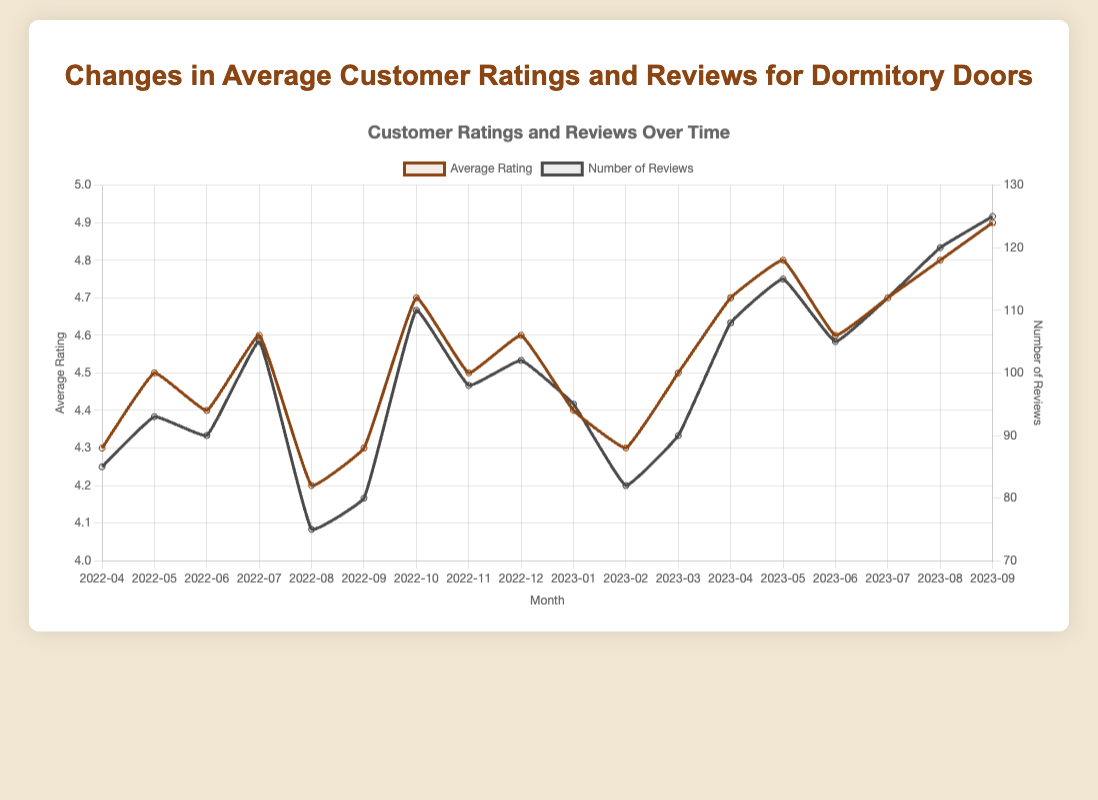What's the range of average customer ratings over the last 18 months? The smallest average rating is 4.2 (August 2022) and the highest is 4.9 (September 2023). The range is calculated as 4.9 - 4.2.
Answer: 0.7 Which month had the highest number of reviews, and what was the average rating that month? September 2023 had the highest number of reviews with 125 reviews, and the average rating that month was 4.9.
Answer: September 2023, 4.9 What is the average number of reviews per month over the last 18 months? Sum the number of reviews for each month: 85 + 93 + 90 + 105 + 75 + 80 + 110 + 98 + 102 + 95 + 82 + 90 + 108 + 115 + 105 + 112 + 120 + 125, then divide by 18. (1670/18)
Answer: 92.78 How did the average customer rating change from April 2022 to September 2023? The average rating in April 2022 was 4.3 and it increased to 4.9 in September 2023. The change is calculated as 4.9 - 4.3.
Answer: +0.6 Which two consecutive months show the largest increase in average ratings? Compare the difference in average ratings between consecutive months and find the largest increase. Between September 2022 (4.3) and October 2022 (4.7), the increase is 0.4, which is the largest.
Answer: September to October 2022 During which month did the reviews decrease while the average rating increased, compared to the previous month? Compare the number of reviews and average rating month over month. From June (90 reviews, 4.4) to July 2022 (105 reviews, 4.6), reviews decreased from 105 to 75 in August 2022 but the average rating increased from 4.6 to 4.2.
Answer: August 2022 What trend do you observe in the number of reviews from February 2023 to September 2023? The trend in the number of reviews is increasing each month from February 2023 (82 reviews) to September 2023 (125 reviews).
Answer: Increasing In which month did the average rating equal the average rating of the entire period? Calculate the overall average rating and compare it to the monthly averages. Overall average rating is (4.3+4.5+4.4+4.6+4.2+4.3+4.7+4.5+4.6+4.4+4.3+4.5+4.7+4.8+4.6+4.7+4.8+4.9)/18 = 4.566. The closest month is November 2022 with 4.5, which rounds off.
Answer: November 2022 What pattern do you observe between the months with the highest average ratings and the number of reviews? The months with the highest average ratings (4.8 and 4.9) generally correspond to months with higher numbers of reviews (115, 120, and 125).
Answer: Higher numbers of reviews generally correspond with high average ratings 